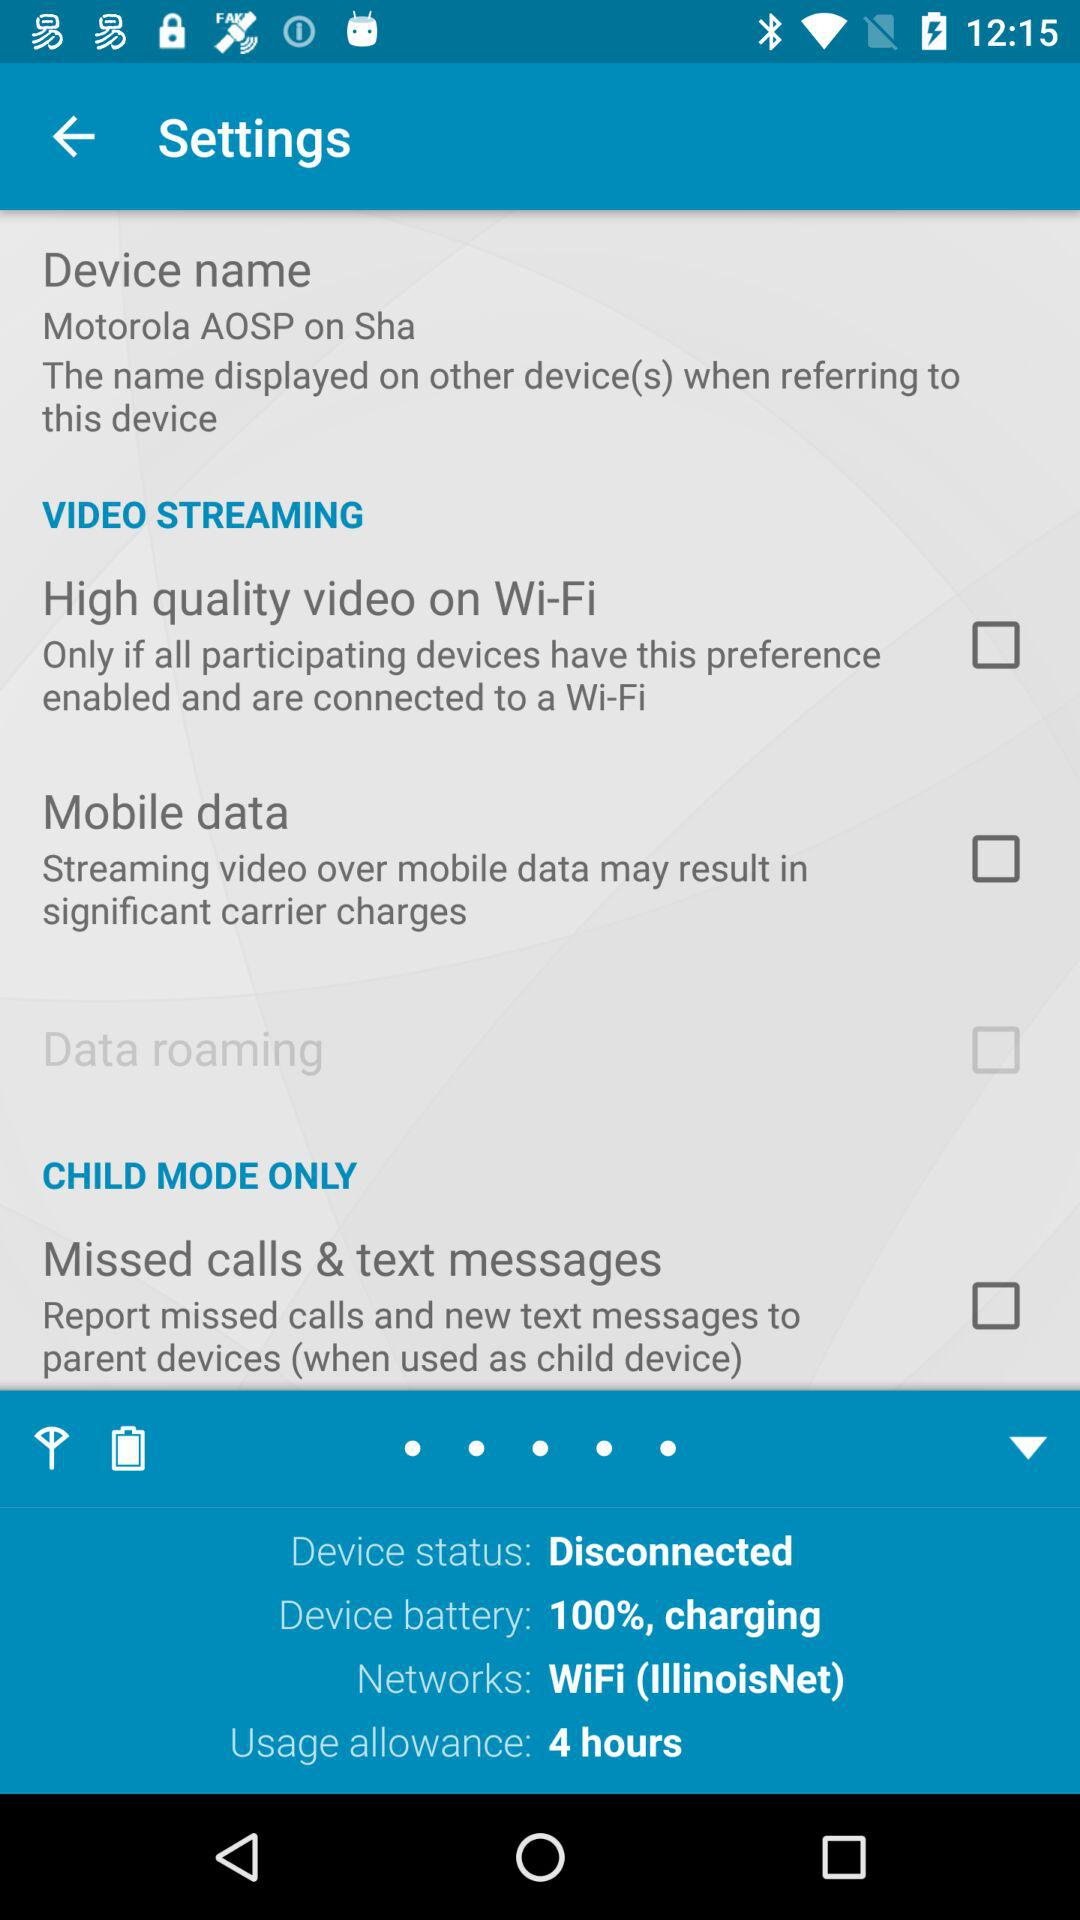What is the "Device status"? The "Device status" is "Disconnected". 